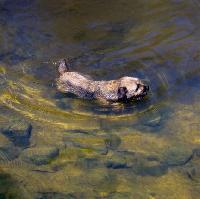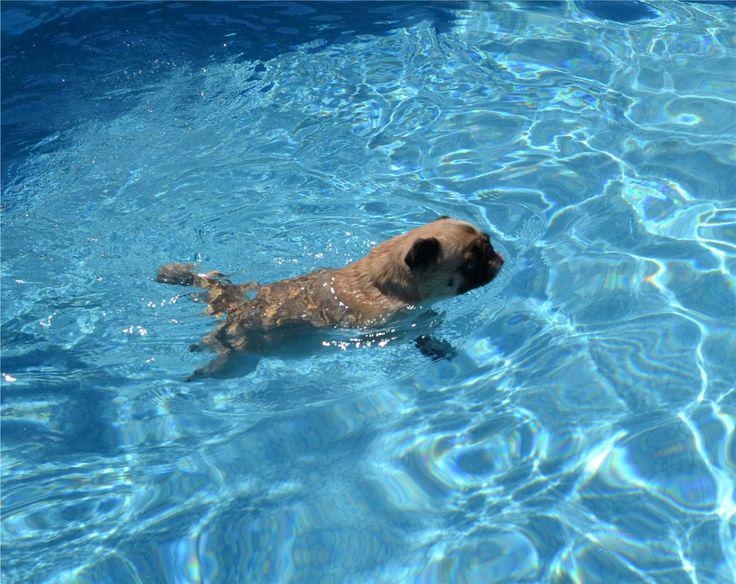The first image is the image on the left, the second image is the image on the right. Evaluate the accuracy of this statement regarding the images: "The dog in the image on the left is swimming in a pool.". Is it true? Answer yes or no. No. The first image is the image on the left, the second image is the image on the right. Examine the images to the left and right. Is the description "A forward-headed dog is staying afloat by means of some item that floats." accurate? Answer yes or no. No. 